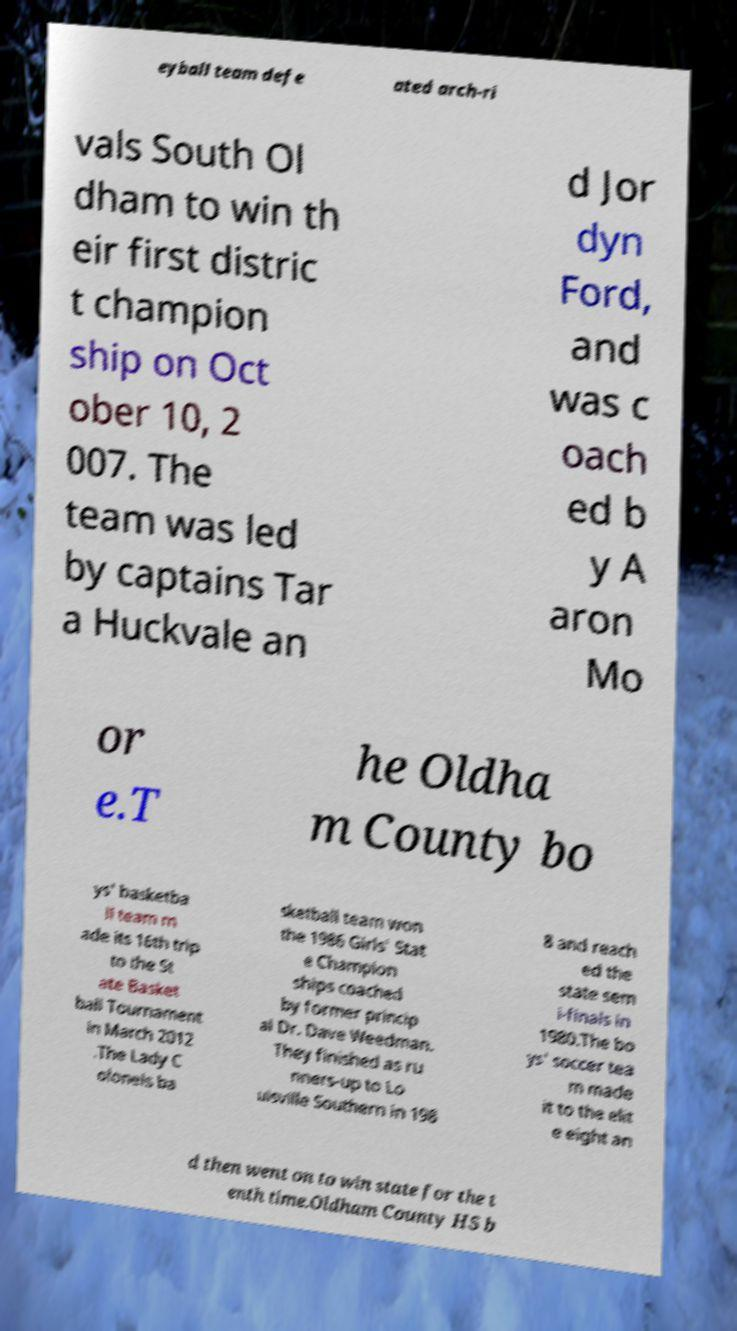For documentation purposes, I need the text within this image transcribed. Could you provide that? eyball team defe ated arch-ri vals South Ol dham to win th eir first distric t champion ship on Oct ober 10, 2 007. The team was led by captains Tar a Huckvale an d Jor dyn Ford, and was c oach ed b y A aron Mo or e.T he Oldha m County bo ys' basketba ll team m ade its 16th trip to the St ate Basket ball Tournament in March 2012 .The Lady C olonels ba sketball team won the 1986 Girls' Stat e Champion ships coached by former princip al Dr. Dave Weedman. They finished as ru nners-up to Lo uisville Southern in 198 8 and reach ed the state sem i-finals in 1980.The bo ys' soccer tea m made it to the elit e eight an d then went on to win state for the t enth time.Oldham County HS b 